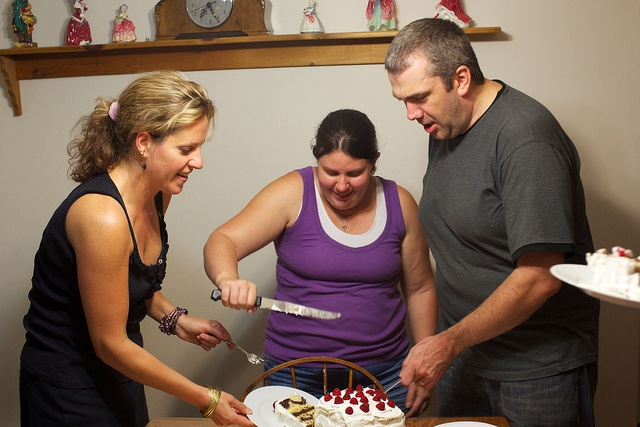Describe the objects in this image and their specific colors. I can see people in gray, black, maroon, and brown tones, people in gray, black, brown, tan, and maroon tones, people in gray, purple, black, tan, and brown tones, cake in gray, ivory, tan, maroon, and brown tones, and chair in gray, black, maroon, and navy tones in this image. 